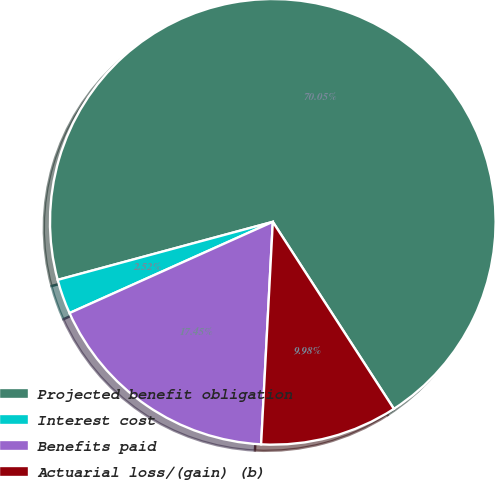<chart> <loc_0><loc_0><loc_500><loc_500><pie_chart><fcel>Projected benefit obligation<fcel>Interest cost<fcel>Benefits paid<fcel>Actuarial loss/(gain) (b)<nl><fcel>70.05%<fcel>2.52%<fcel>17.45%<fcel>9.98%<nl></chart> 